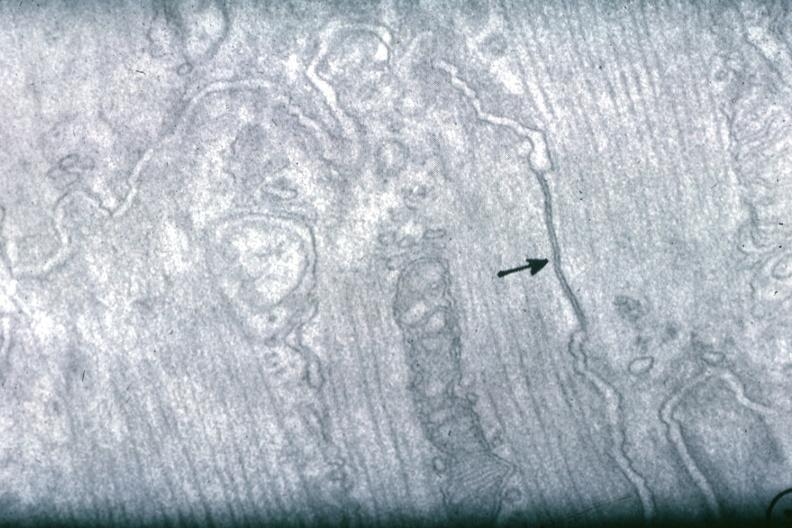where does this image show junctional complex?
Answer the question using a single word or phrase. Between two cells 